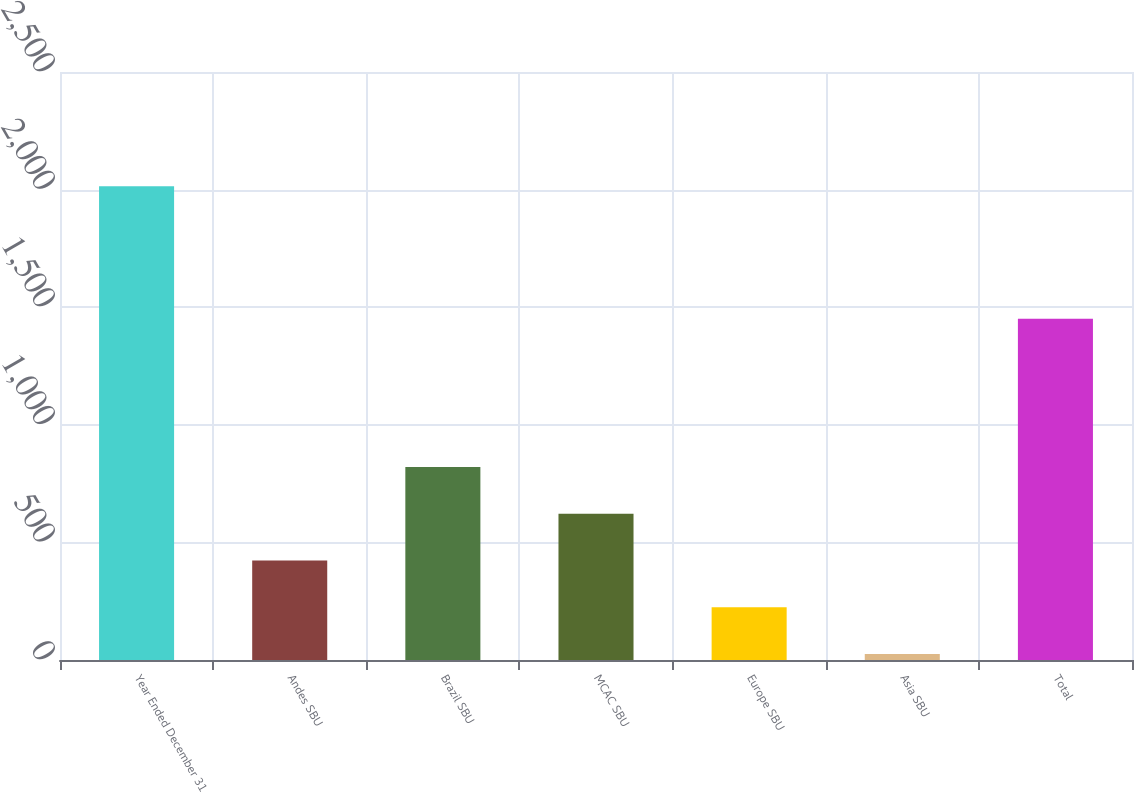Convert chart to OTSL. <chart><loc_0><loc_0><loc_500><loc_500><bar_chart><fcel>Year Ended December 31<fcel>Andes SBU<fcel>Brazil SBU<fcel>MCAC SBU<fcel>Europe SBU<fcel>Asia SBU<fcel>Total<nl><fcel>2014<fcel>422.8<fcel>820.6<fcel>621.7<fcel>223.9<fcel>25<fcel>1451<nl></chart> 